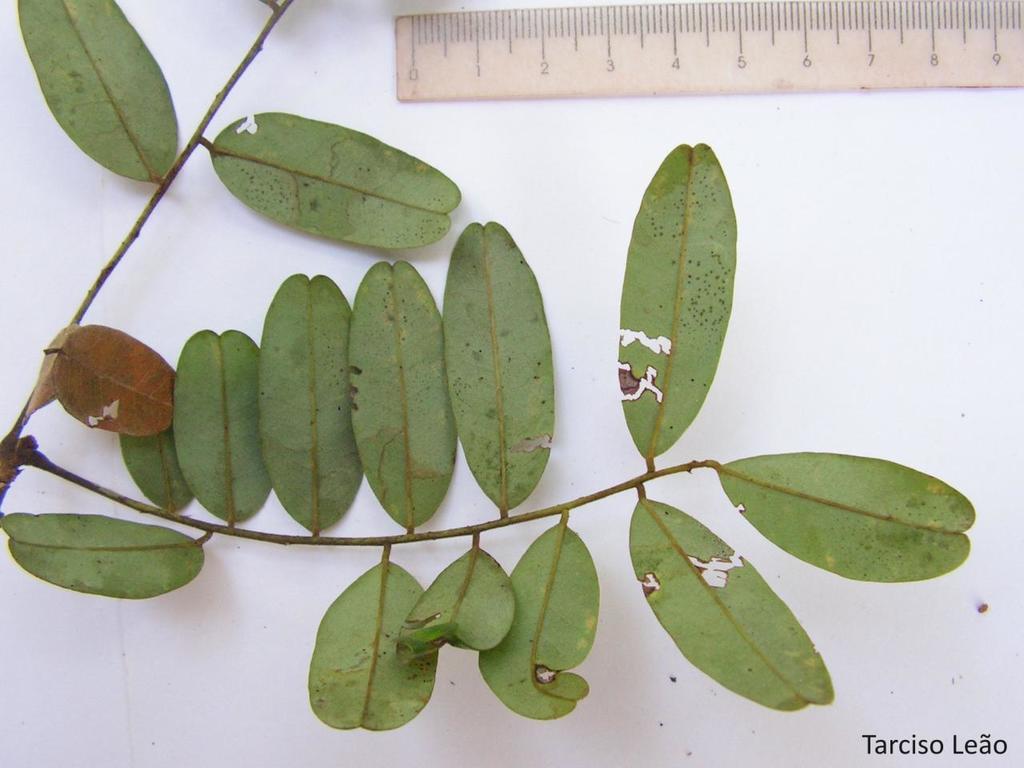Can you describe this image briefly? In this image I can see the plant with leaves. To the side I can see the scale. These are on the white color surface. 